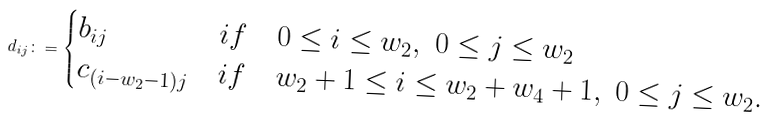<formula> <loc_0><loc_0><loc_500><loc_500>d _ { i j } \colon = \begin{cases} b _ { i j } & i f \quad 0 \leq i \leq w _ { 2 } , \ 0 \leq j \leq w _ { 2 } \\ c _ { ( i - w _ { 2 } - 1 ) j } & i f \quad w _ { 2 } + 1 \leq i \leq w _ { 2 } + w _ { 4 } + 1 , \ 0 \leq j \leq w _ { 2 } . \end{cases}</formula> 